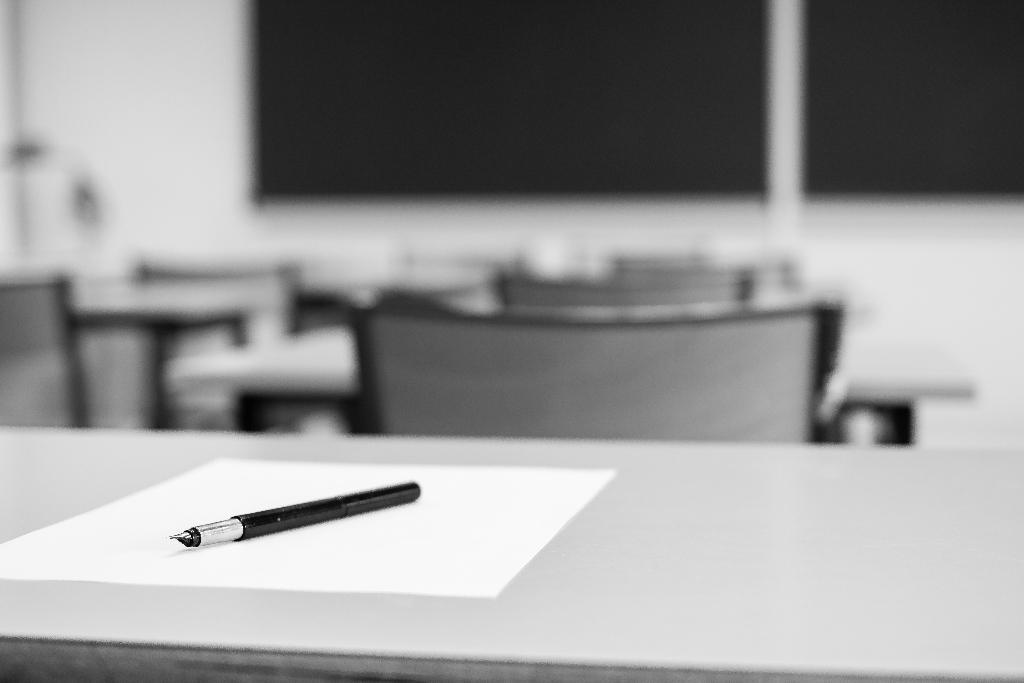What stationary item is on the table in the image? There is a pen on the table in the image. What is the pen used for in the image? The pen is likely used for writing on the paper, which is also on the table. Where are the pen and paper located in the image? The pen and paper are located at the bottom side of the image. What can be seen in the background of the image? There are chairs, tables, and windows in the background of the image. What type of thread is being used to sew the sky in the image? There is no thread or sewing activity present in the image; it features a pen and paper on a table with chairs, tables, and windows in the background. 